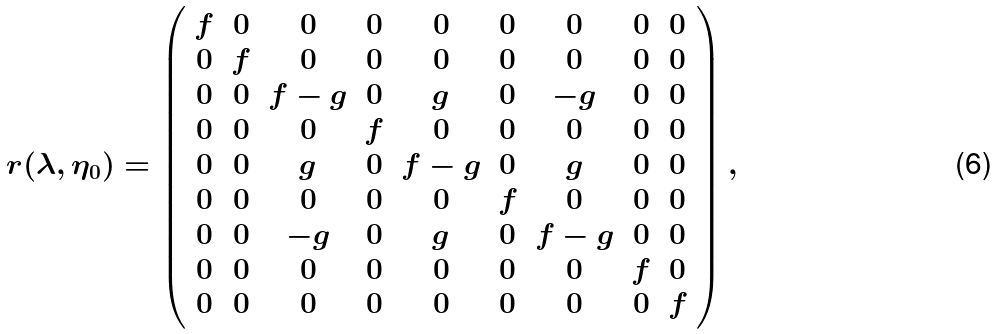<formula> <loc_0><loc_0><loc_500><loc_500>r ( \lambda , \eta _ { 0 } ) = \left ( \begin{array} { c c c c c c c c c } f & 0 & 0 & 0 & 0 & 0 & 0 & 0 & 0 \\ 0 & f & 0 & 0 & 0 & 0 & 0 & 0 & 0 \\ 0 & 0 & f - g & 0 & g & 0 & - g & 0 & 0 \\ 0 & 0 & 0 & f & 0 & 0 & 0 & 0 & 0 \\ 0 & 0 & g & 0 & f - g & 0 & g & 0 & 0 \\ 0 & 0 & 0 & 0 & 0 & f & 0 & 0 & 0 \\ 0 & 0 & - g & 0 & g & 0 & f - g & 0 & 0 \\ 0 & 0 & 0 & 0 & 0 & 0 & 0 & f & 0 \\ 0 & 0 & 0 & 0 & 0 & 0 & 0 & 0 & f \end{array} \right ) ,</formula> 